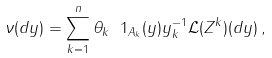<formula> <loc_0><loc_0><loc_500><loc_500>\nu ( d y ) = \sum _ { k = 1 } ^ { n } \theta _ { k } \ 1 _ { A _ { k } } ( y ) y _ { k } ^ { - 1 } \mathcal { L } ( Z ^ { k } ) ( d y ) \, ,</formula> 